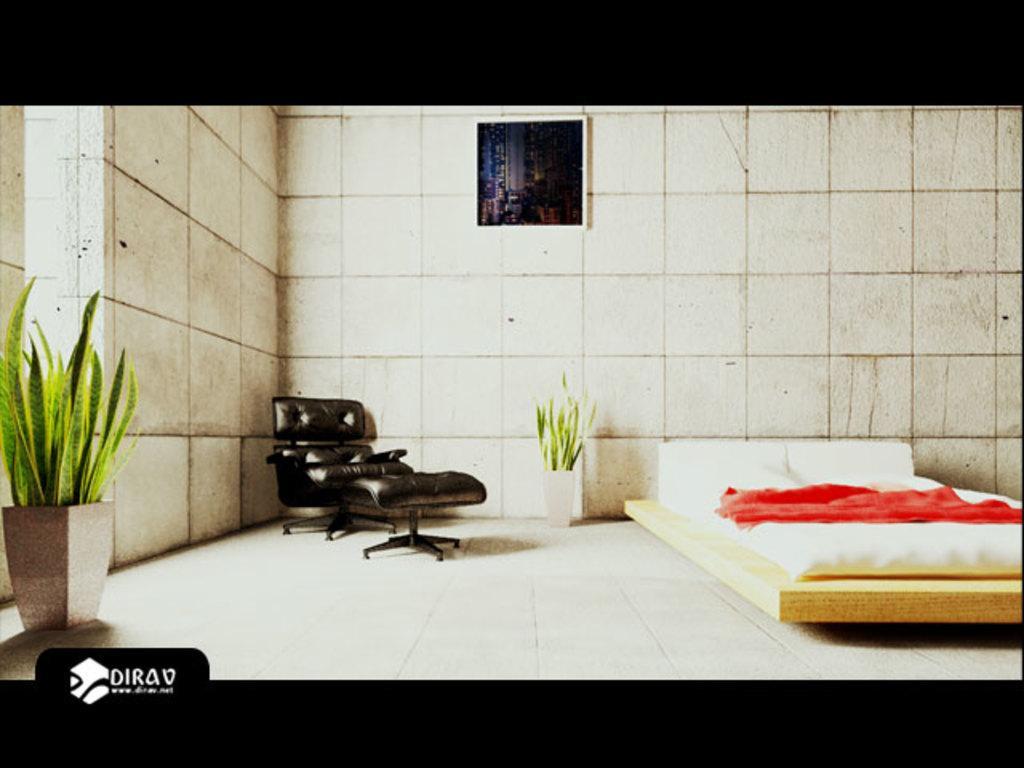In one or two sentences, can you explain what this image depicts? In the image on the right side there is a bed with pillows and bed sheet. Beside the bed there is a potted plant. And also there is a sofa chair. There is a wall with frame. On the left corner of the image there is a potted plant. And also there is a logo with name. 